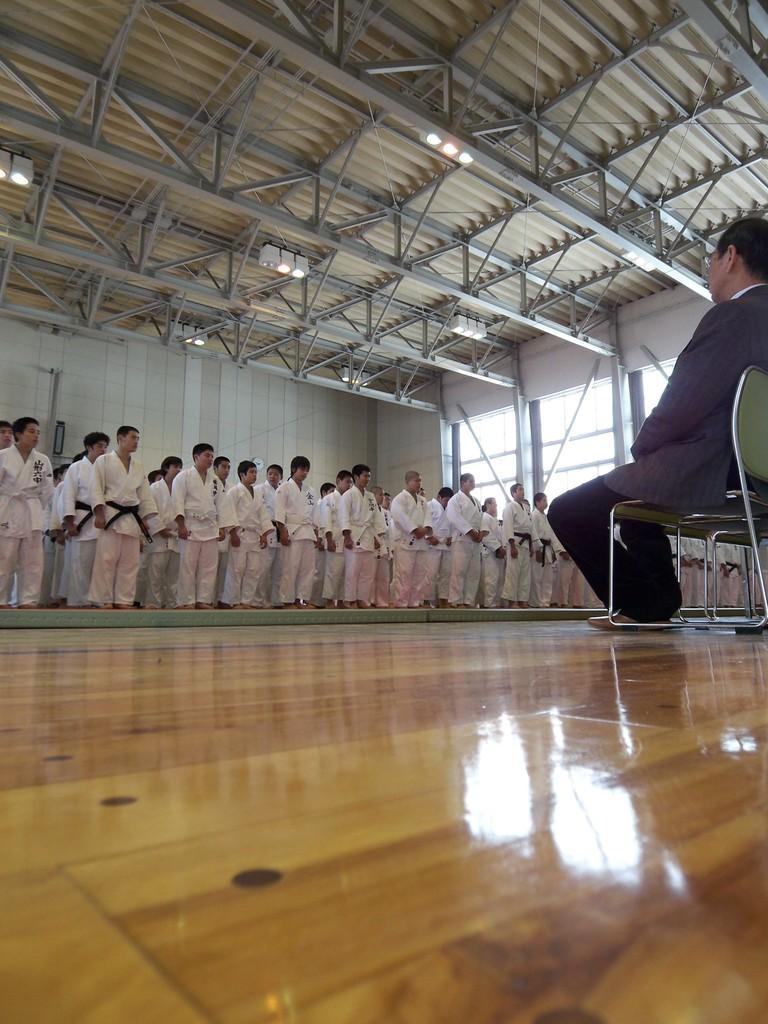Can you describe this image briefly? There are group of people standing. they wore karate dress. Here is another person sitting on the chair. This is the wooden floor. These are the lights attached to the rooftop. I think these are the windows. This roof top is made of metal and iron sheets. 